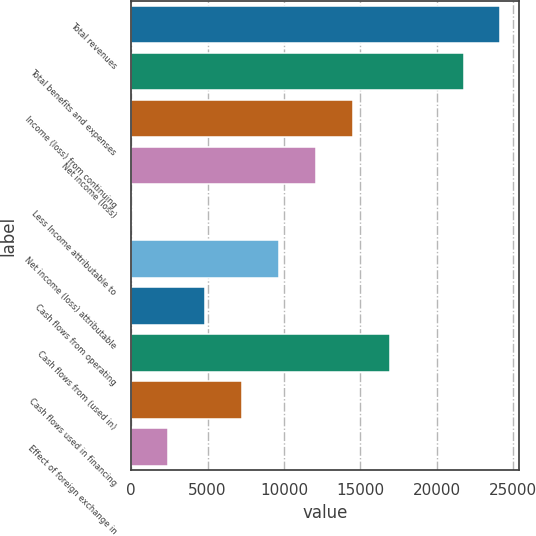<chart> <loc_0><loc_0><loc_500><loc_500><bar_chart><fcel>Total revenues<fcel>Total benefits and expenses<fcel>Income (loss) from continuing<fcel>Net income (loss)<fcel>Less Income attributable to<fcel>Net income (loss) attributable<fcel>Cash flows from operating<fcel>Cash flows from (used in)<fcel>Cash flows used in financing<fcel>Effect of foreign exchange in<nl><fcel>24173<fcel>21755.8<fcel>14504.2<fcel>12087<fcel>1<fcel>9669.8<fcel>4835.4<fcel>16921.4<fcel>7252.6<fcel>2418.2<nl></chart> 